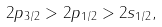<formula> <loc_0><loc_0><loc_500><loc_500>2 p _ { 3 / 2 } > 2 p _ { 1 / 2 } > 2 s _ { 1 / 2 } ,</formula> 